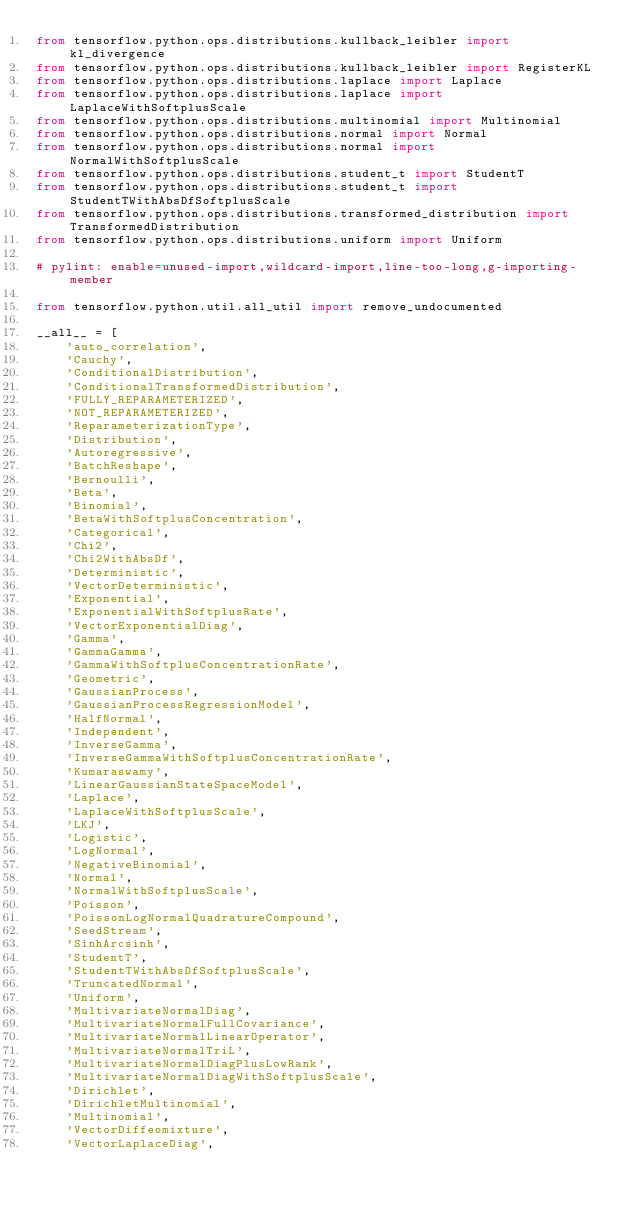Convert code to text. <code><loc_0><loc_0><loc_500><loc_500><_Python_>from tensorflow.python.ops.distributions.kullback_leibler import kl_divergence
from tensorflow.python.ops.distributions.kullback_leibler import RegisterKL
from tensorflow.python.ops.distributions.laplace import Laplace
from tensorflow.python.ops.distributions.laplace import LaplaceWithSoftplusScale
from tensorflow.python.ops.distributions.multinomial import Multinomial
from tensorflow.python.ops.distributions.normal import Normal
from tensorflow.python.ops.distributions.normal import NormalWithSoftplusScale
from tensorflow.python.ops.distributions.student_t import StudentT
from tensorflow.python.ops.distributions.student_t import StudentTWithAbsDfSoftplusScale
from tensorflow.python.ops.distributions.transformed_distribution import TransformedDistribution
from tensorflow.python.ops.distributions.uniform import Uniform

# pylint: enable=unused-import,wildcard-import,line-too-long,g-importing-member

from tensorflow.python.util.all_util import remove_undocumented

__all__ = [
    'auto_correlation',
    'Cauchy',
    'ConditionalDistribution',
    'ConditionalTransformedDistribution',
    'FULLY_REPARAMETERIZED',
    'NOT_REPARAMETERIZED',
    'ReparameterizationType',
    'Distribution',
    'Autoregressive',
    'BatchReshape',
    'Bernoulli',
    'Beta',
    'Binomial',
    'BetaWithSoftplusConcentration',
    'Categorical',
    'Chi2',
    'Chi2WithAbsDf',
    'Deterministic',
    'VectorDeterministic',
    'Exponential',
    'ExponentialWithSoftplusRate',
    'VectorExponentialDiag',
    'Gamma',
    'GammaGamma',
    'GammaWithSoftplusConcentrationRate',
    'Geometric',
    'GaussianProcess',
    'GaussianProcessRegressionModel',
    'HalfNormal',
    'Independent',
    'InverseGamma',
    'InverseGammaWithSoftplusConcentrationRate',
    'Kumaraswamy',
    'LinearGaussianStateSpaceModel',
    'Laplace',
    'LaplaceWithSoftplusScale',
    'LKJ',
    'Logistic',
    'LogNormal',
    'NegativeBinomial',
    'Normal',
    'NormalWithSoftplusScale',
    'Poisson',
    'PoissonLogNormalQuadratureCompound',
    'SeedStream',
    'SinhArcsinh',
    'StudentT',
    'StudentTWithAbsDfSoftplusScale',
    'TruncatedNormal',
    'Uniform',
    'MultivariateNormalDiag',
    'MultivariateNormalFullCovariance',
    'MultivariateNormalLinearOperator',
    'MultivariateNormalTriL',
    'MultivariateNormalDiagPlusLowRank',
    'MultivariateNormalDiagWithSoftplusScale',
    'Dirichlet',
    'DirichletMultinomial',
    'Multinomial',
    'VectorDiffeomixture',
    'VectorLaplaceDiag',</code> 